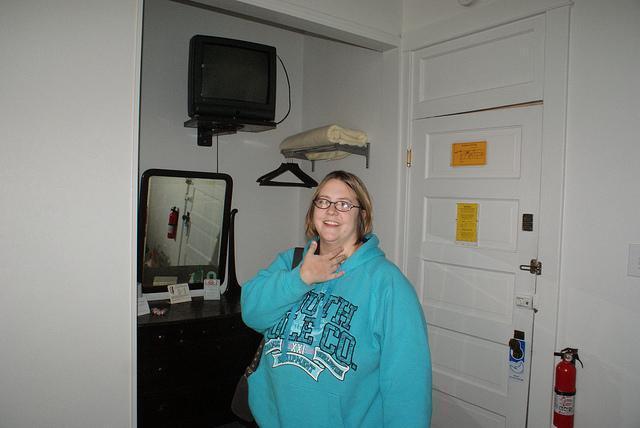How many stripes are visible?
Give a very brief answer. 0. How many of the people in this photo are carrying a surfboard?
Give a very brief answer. 0. 